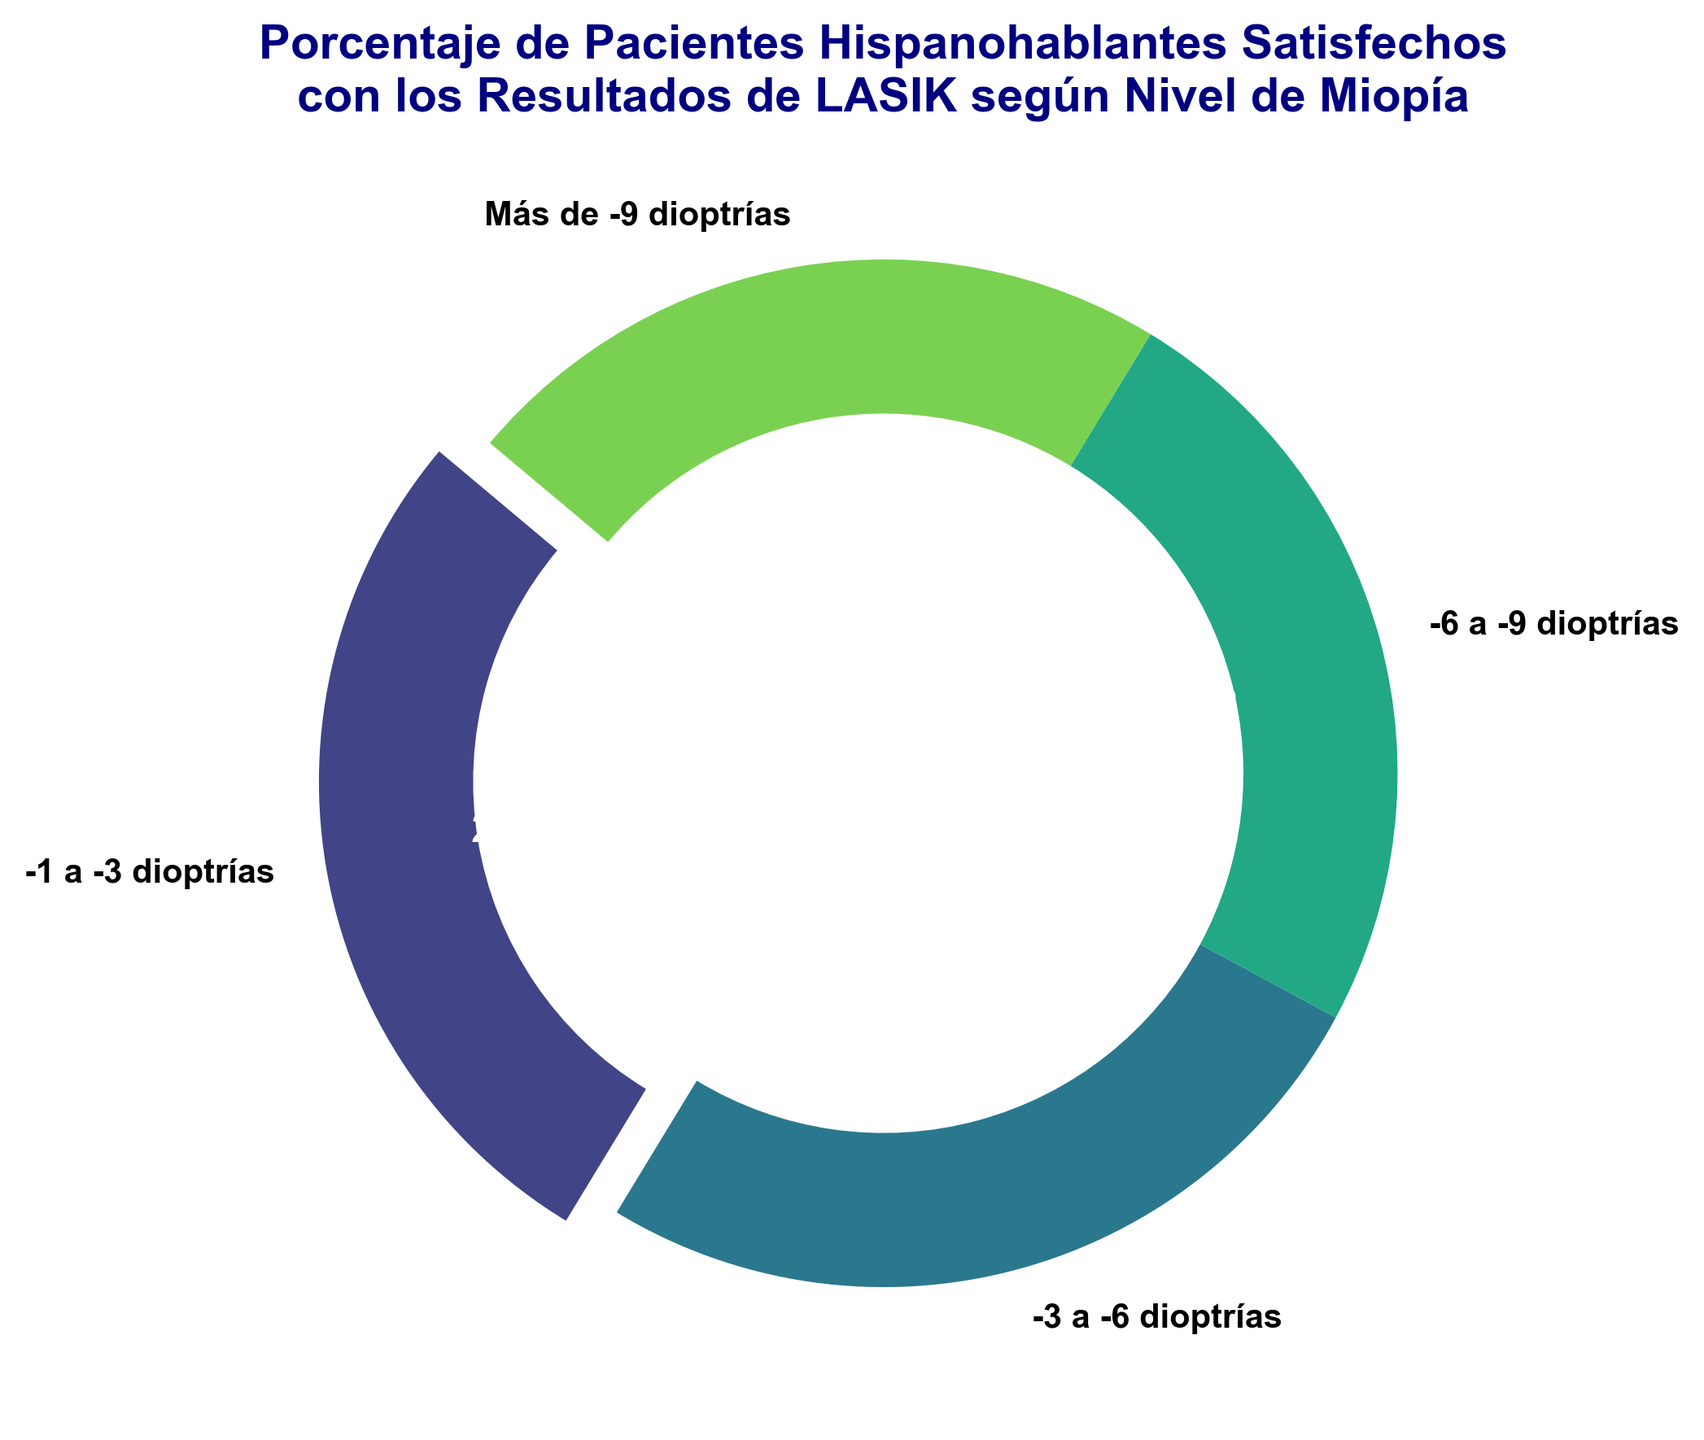¿Cuál es el grupo con el mayor porcentaje de satisfacción? El grupo con el mayor porcentaje de satisfacción es el que tiene el porcentaje más alto en el gráfico. Observamos que los niveles de miopía de -1 a -3 dioptrías tienen un porcentaje de satisfacción del 85%, que es el más alto de todos.
Answer: Nivel de miopía de -1 a -3 dioptrías ¿Cuál es el porcentaje de satisfacción para pacientes con miopía de más de -9 dioptrías? Para encontrar este porcentaje, buscamos la etiqueta correspondiente a "Más de -9 dioptrías" en el gráfico. El porcentaje de satisfacción asociado es del 70%.
Answer: 70% ¿Cuánto mayor es la satisfacción de los pacientes con miopía de -1 a -3 dioptrías comparado con la satisfacción de los pacientes con miopía de -3 a -6 dioptrías? Para calcular esta diferencia, restamos el porcentaje de satisfacción de los pacientes de -3 a -6 dioptrías al porcentaje de los pacientes de -1 a -3 dioptrías. Es decir, 85% - 80% = 5%.
Answer: 5% ¿Cuál es la diferencia entre el porcentaje de satisfacción más alto y el más bajo? Primero encontramos el porcentaje de satisfacción más alto (85% para -1 a -3 dioptrías) y el más bajo (70% para más de -9 dioptrías). La diferencia es 85% - 70% = 15%.
Answer: 15% ¿Cuál es el color de la porción más grande del gráfico? Observamos el gráfico y encontramos que la porción más grande, que representa a los pacientes con miopía -1 a -3 dioptrías, está destacada. El color de esta porción, según el esquema de colores viridis, es un tono más claro (verde claro).
Answer: Verde claro ¿Cuál es el promedio de satisfacción de todos los grupos de miopía? Para calcular el promedio, sumamos todos los porcentajes de satisfacción (85% + 80% + 75% + 70%) y dividimos por el número de grupos (4). El cálculo es (85 + 80 + 75 + 70) / 4 = 310 / 4 = 77.5%.
Answer: 77.5% ¿Qué nivel de miopía tiene una satisfacción igual al promedio de satisfacción general? Primero calculamos el promedio de satisfacción que ya vimos es 77.5%. Luego comparamos con los porcentajes de cada nivel de miopía. Observamos que ningún nivel de miopía tiene exactamente el 77.5%, aunque el nivel de -6 a -9 dioptrías está más cercano con 75%.
Answer: Ninguno (más cercano -6 a -9 dioptrías) ¿Cuál es el rango de satisfacción mostrado en el gráfico? El rango se calcula restando el porcentaje más bajo (70% para más de -9 dioptrías) del porcentaje más alto (85% para -1 a -3 dioptrías). Esto da 85% - 70% = 15%.
Answer: 15% 